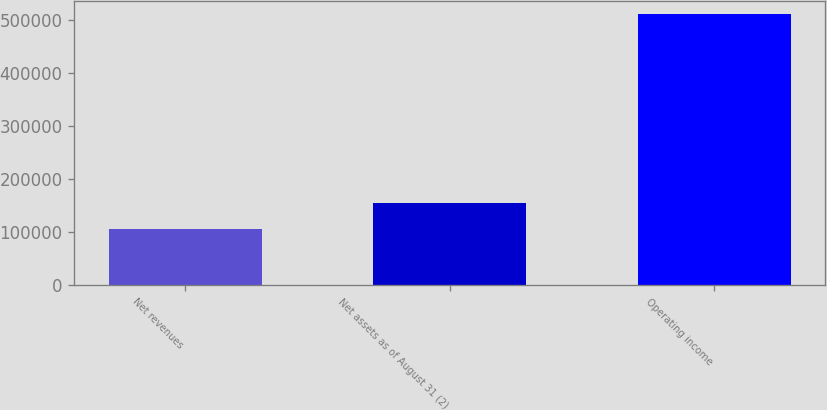Convert chart. <chart><loc_0><loc_0><loc_500><loc_500><bar_chart><fcel>Net revenues<fcel>Net assets as of August 31 (2)<fcel>Operating income<nl><fcel>104709<fcel>153725<fcel>509793<nl></chart> 